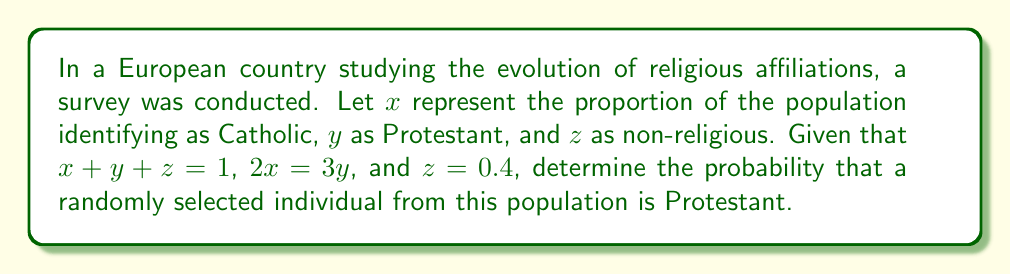Can you answer this question? Let's approach this step-by-step:

1) We know that the total proportion must equal 1:
   $$x + y + z = 1$$

2) We're given that $z = 0.4$, so we can substitute this:
   $$x + y + 0.4 = 1$$

3) We're also told that $2x = 3y$. Let's rearrange this to express $x$ in terms of $y$:
   $$x = \frac{3y}{2}$$

4) Now, let's substitute this into our equation from step 2:
   $$\frac{3y}{2} + y + 0.4 = 1$$

5) Simplify:
   $$\frac{3y}{2} + \frac{2y}{2} + 0.4 = 1$$
   $$\frac{5y}{2} + 0.4 = 1$$

6) Subtract 0.4 from both sides:
   $$\frac{5y}{2} = 0.6$$

7) Multiply both sides by 2:
   $$5y = 1.2$$

8) Divide both sides by 5:
   $$y = 0.24$$

Therefore, the probability that a randomly selected individual is Protestant is 0.24 or 24%.
Answer: 0.24 